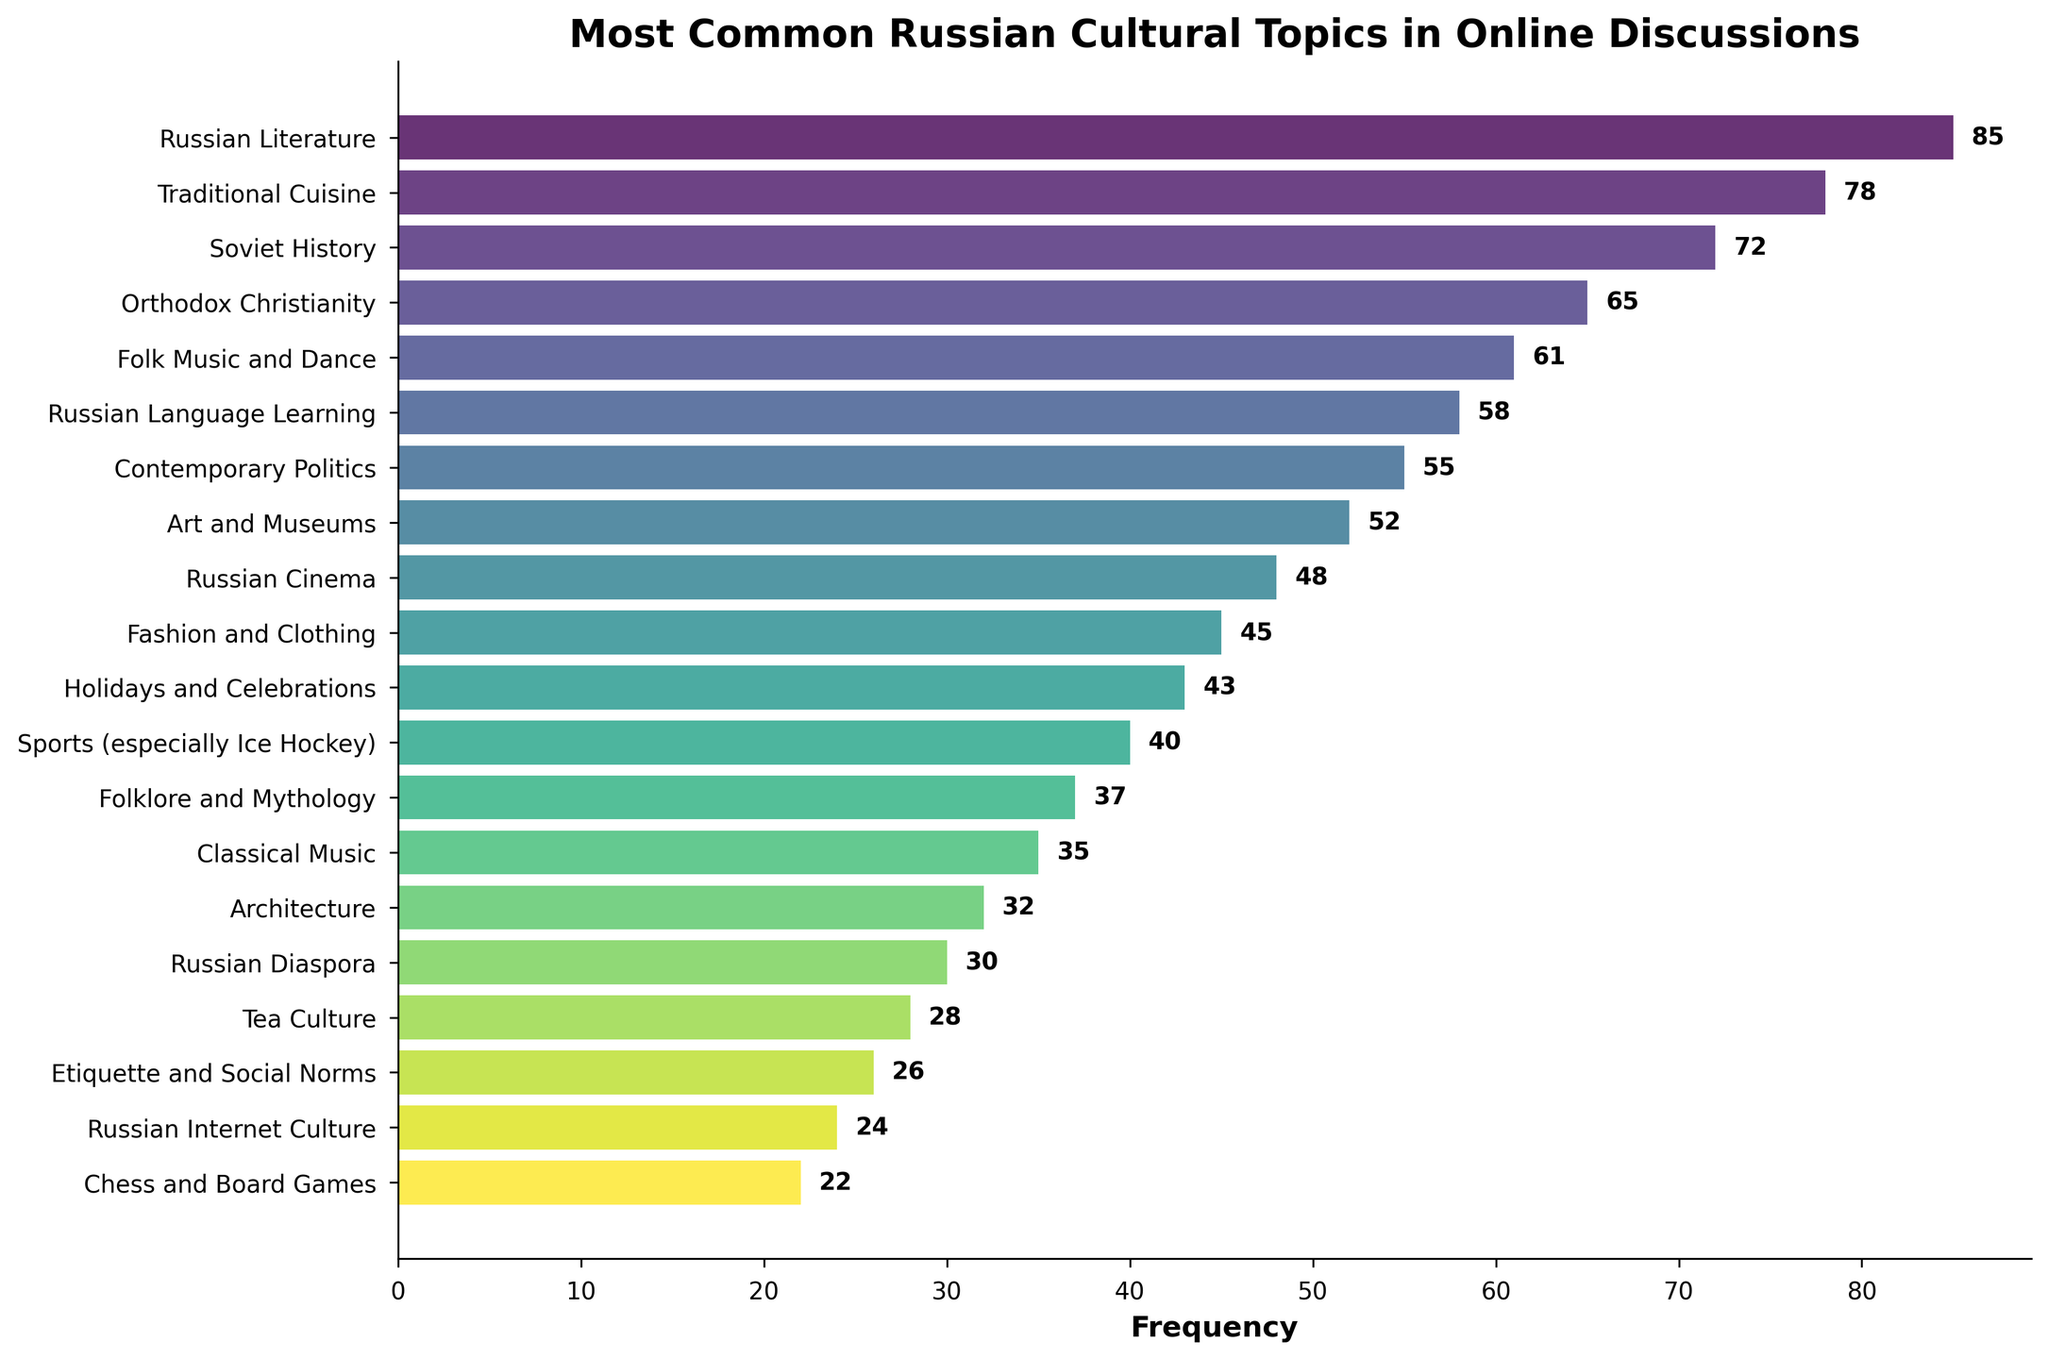What is the most common Russian cultural topic discussed in online forums and social media? The bar representing "Russian Literature" is the longest, indicating it has the highest frequency.
Answer: Russian Literature Which topics have more discussions compared to "Orthodox Christianity"? Any topic with a longer bar than "Orthodox Christianity" has more discussions. These include "Russian Literature", "Traditional Cuisine", and "Soviet History".
Answer: Russian Literature, Traditional Cuisine, Soviet History How many more times is "Russian Literature" discussed compared to "Russian Language Learning"? Subtract the frequency of "Russian Language Learning" from "Russian Literature" (85 - 58).
Answer: 27 Which topics have less than 30 mentions? All bars shorter than the bar representing 30 mentions correspond to the topics with less than 30 mentions. These topics are "Tea Culture", "Etiquette and Social Norms", "Russian Internet Culture", and "Chess and Board Games".
Answer: Tea Culture, Etiquette and Social Norms, Russian Internet Culture, Chess and Board Games What is the difference in frequency between the most and least discussed topics? Subtract the frequency of the least discussed topic "Chess and Board Games" (22) from the most discussed "Russian Literature" (85).
Answer: 63 Are there more mentions of "Contemporary Politics" or "Fashion and Clothing"? Compare the lengths of the bars for "Contemporary Politics" (55) and "Fashion and Clothing" (45).
Answer: Contemporary Politics What is the combined frequency of discussions about "Folk Music and Dance" and "Russian Cinema"? Add the frequencies of "Folk Music and Dance" (61) and "Russian Cinema" (48).
Answer: 109 Which topic has just over half the discussions of "Russian Literature"? Find the topic whose frequency is around half of 85, which is approximately 42.5. "Holidays and Celebrations" has a frequency of 43, which is just over half.
Answer: Holidays and Celebrations List the topics that are discussed more frequently than "Sports (especially Ice Hockey)" but less frequently than "Traditional Cuisine". Identify topics with frequencies between 40 and 78. These include "Soviet History", "Orthodox Christianity", "Folk Music and Dance", "Russian Language Learning", and "Contemporary Politics".
Answer: Soviet History, Orthodox Christianity, Folk Music and Dance, Russian Language Learning, Contemporary Politics What is the total frequency of the top three most discussed topics? Sum the frequencies of "Russian Literature" (85), "Traditional Cuisine" (78), and "Soviet History" (72).
Answer: 235 